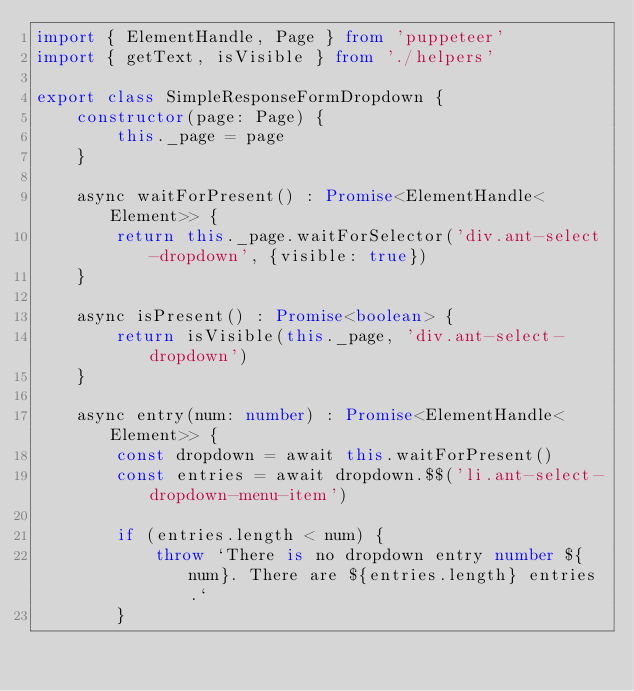<code> <loc_0><loc_0><loc_500><loc_500><_TypeScript_>import { ElementHandle, Page } from 'puppeteer'
import { getText, isVisible } from './helpers'

export class SimpleResponseFormDropdown {
    constructor(page: Page) {
        this._page = page
    }

    async waitForPresent() : Promise<ElementHandle<Element>> {
        return this._page.waitForSelector('div.ant-select-dropdown', {visible: true})
    }

    async isPresent() : Promise<boolean> {
        return isVisible(this._page, 'div.ant-select-dropdown')
    }

    async entry(num: number) : Promise<ElementHandle<Element>> {
        const dropdown = await this.waitForPresent()
        const entries = await dropdown.$$('li.ant-select-dropdown-menu-item')

        if (entries.length < num) {
            throw `There is no dropdown entry number ${num}. There are ${entries.length} entries.`
        }
</code> 